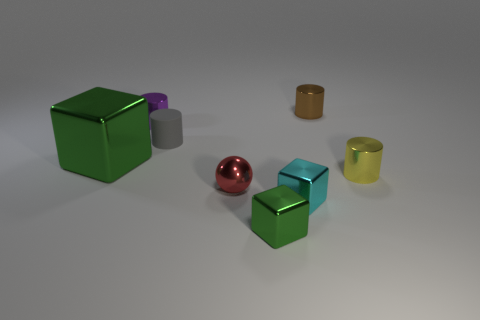What number of cubes have the same color as the large thing?
Your answer should be very brief. 1. Are there the same number of small objects on the right side of the tiny red metallic object and cylinders?
Make the answer very short. Yes. How many spheres are either big yellow shiny things or small gray things?
Keep it short and to the point. 0. Is the number of tiny yellow shiny cylinders that are on the left side of the tiny green metallic thing the same as the number of objects that are to the right of the small rubber thing?
Offer a very short reply. No. What is the color of the big object?
Give a very brief answer. Green. What number of objects are either green shiny objects behind the yellow shiny object or yellow metal objects?
Make the answer very short. 2. There is a green metal cube in front of the tiny red thing; is it the same size as the metallic cylinder left of the small gray matte thing?
Provide a short and direct response. Yes. Is there any other thing that has the same material as the gray thing?
Keep it short and to the point. No. How many things are things that are in front of the big green block or small green shiny blocks that are in front of the yellow shiny thing?
Offer a terse response. 4. Is the material of the large green thing the same as the green object in front of the large green thing?
Provide a short and direct response. Yes. 